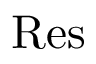<formula> <loc_0><loc_0><loc_500><loc_500>R e s</formula> 